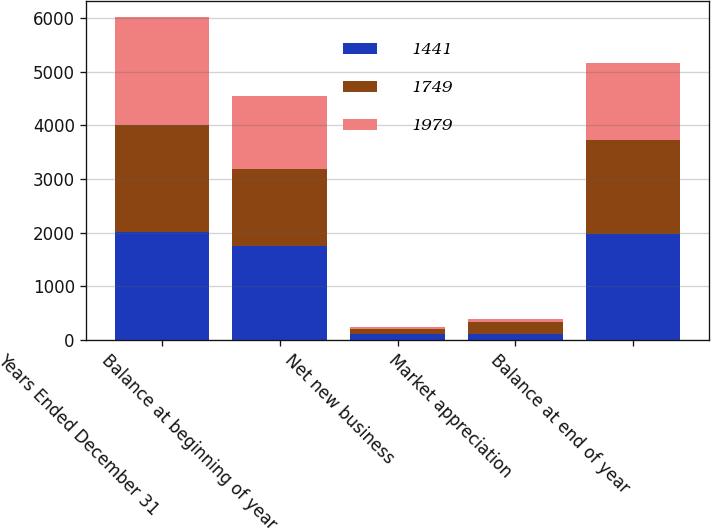Convert chart to OTSL. <chart><loc_0><loc_0><loc_500><loc_500><stacked_bar_chart><ecel><fcel>Years Ended December 31<fcel>Balance at beginning of year<fcel>Net new business<fcel>Market appreciation<fcel>Balance at end of year<nl><fcel>1441<fcel>2007<fcel>1749<fcel>116<fcel>114<fcel>1979<nl><fcel>1749<fcel>2006<fcel>1441<fcel>86<fcel>222<fcel>1749<nl><fcel>1979<fcel>2005<fcel>1354<fcel>36<fcel>51<fcel>1441<nl></chart> 